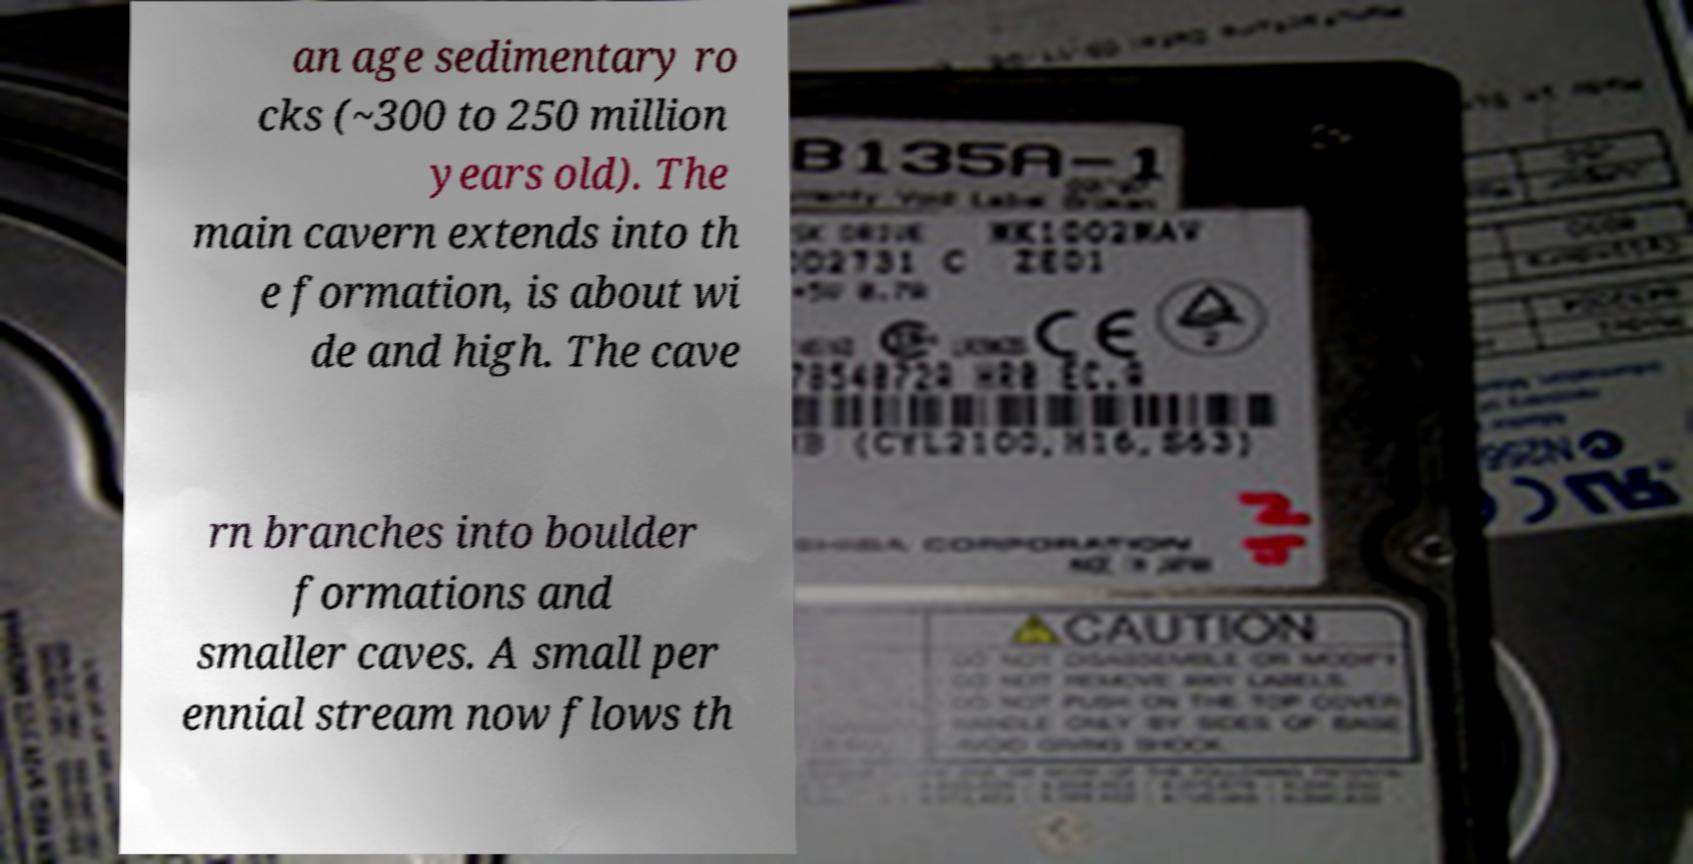Can you accurately transcribe the text from the provided image for me? an age sedimentary ro cks (~300 to 250 million years old). The main cavern extends into th e formation, is about wi de and high. The cave rn branches into boulder formations and smaller caves. A small per ennial stream now flows th 